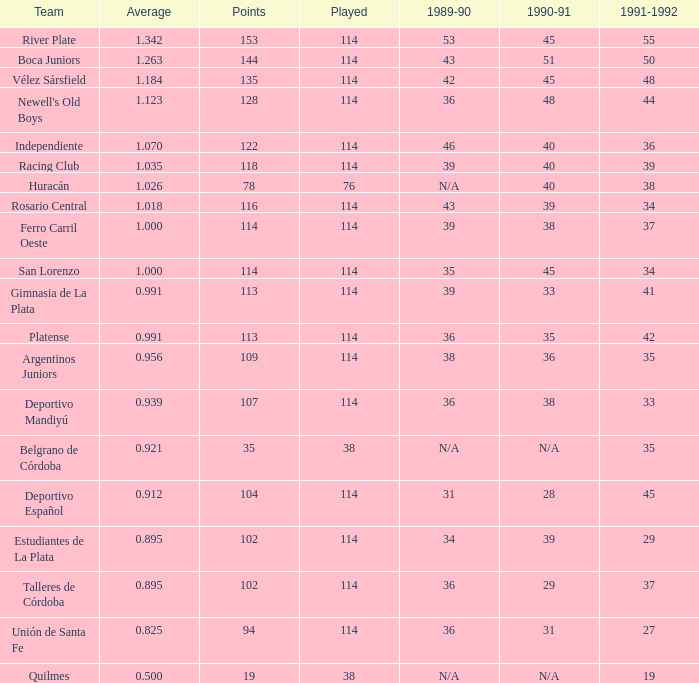What was the score of gimnasia de la plata's team in the 1991-1992 season, and did they achieve over 113 points? 0.0. 